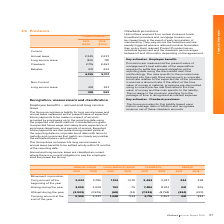According to Iselect's financial document, How are provisions measured? at the present value of management’s best estimate of the expenditure required to settle the present obligation at the reporting date using the discounted cash flow methodology. The document states: "Provisions are measured at the present value of management’s best estimate of the expenditure required to settle the present obligation at the reporti..." Also, What is the range of the clawback period? between 0 and 24 months. The document states: "dividual agreement and the clawback period ranges between 0 and 24 months, depending on the agreement...." Also, How is annual and long service leave classified? classified as current where there is a current obligation to pay the employee shall they leave the Group. The document states: "Annual and long service leave are classified as current where there is a current obligation to pay the employee shall they leave the Group...." Also, can you calculate: What is the percentage change in the annual leave provisions from 2018 to 2019? To answer this question, I need to perform calculations using the financial data. The calculation is: (2,349-2,233)/2,233, which equals 5.19 (percentage). This is based on the information: "Annual leave 2,349 2,233 Annual leave 2,349 2,233..." The key data points involved are: 2,233, 2,349. Also, can you calculate: What is the percentage change in the current provisions from 2018 to 2019? To answer this question, I need to perform calculations using the financial data. The calculation is: (6,135-5,701)/5,701, which equals 7.61 (percentage). This is based on the information: "6,135 5,701 6,135 5,701..." The key data points involved are: 5,701, 6,135. Also, can you calculate: What is the percentage change in the non-current provisions from 2018 to 2019? To answer this question, I need to perform calculations using the financial data. The calculation is: (418-343)/343, which equals 21.87 (percentage). This is based on the information: "Long service leave 418 343 Long service leave 418 343..." The key data points involved are: 343, 418. 